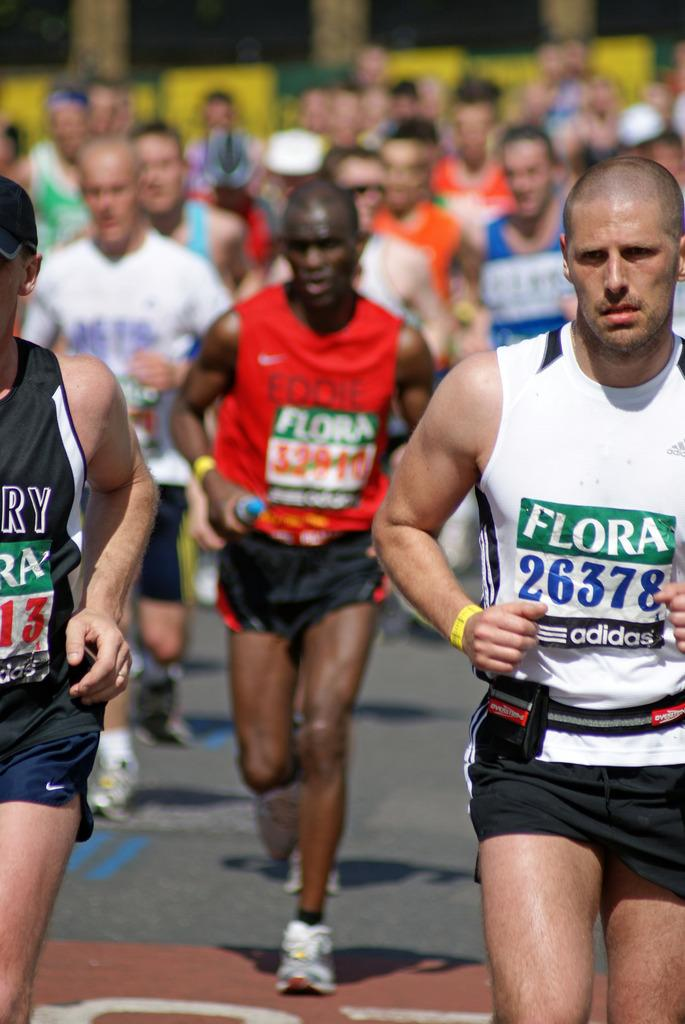Provide a one-sentence caption for the provided image. People running in a marathon with the print  Flora on their shirts. 